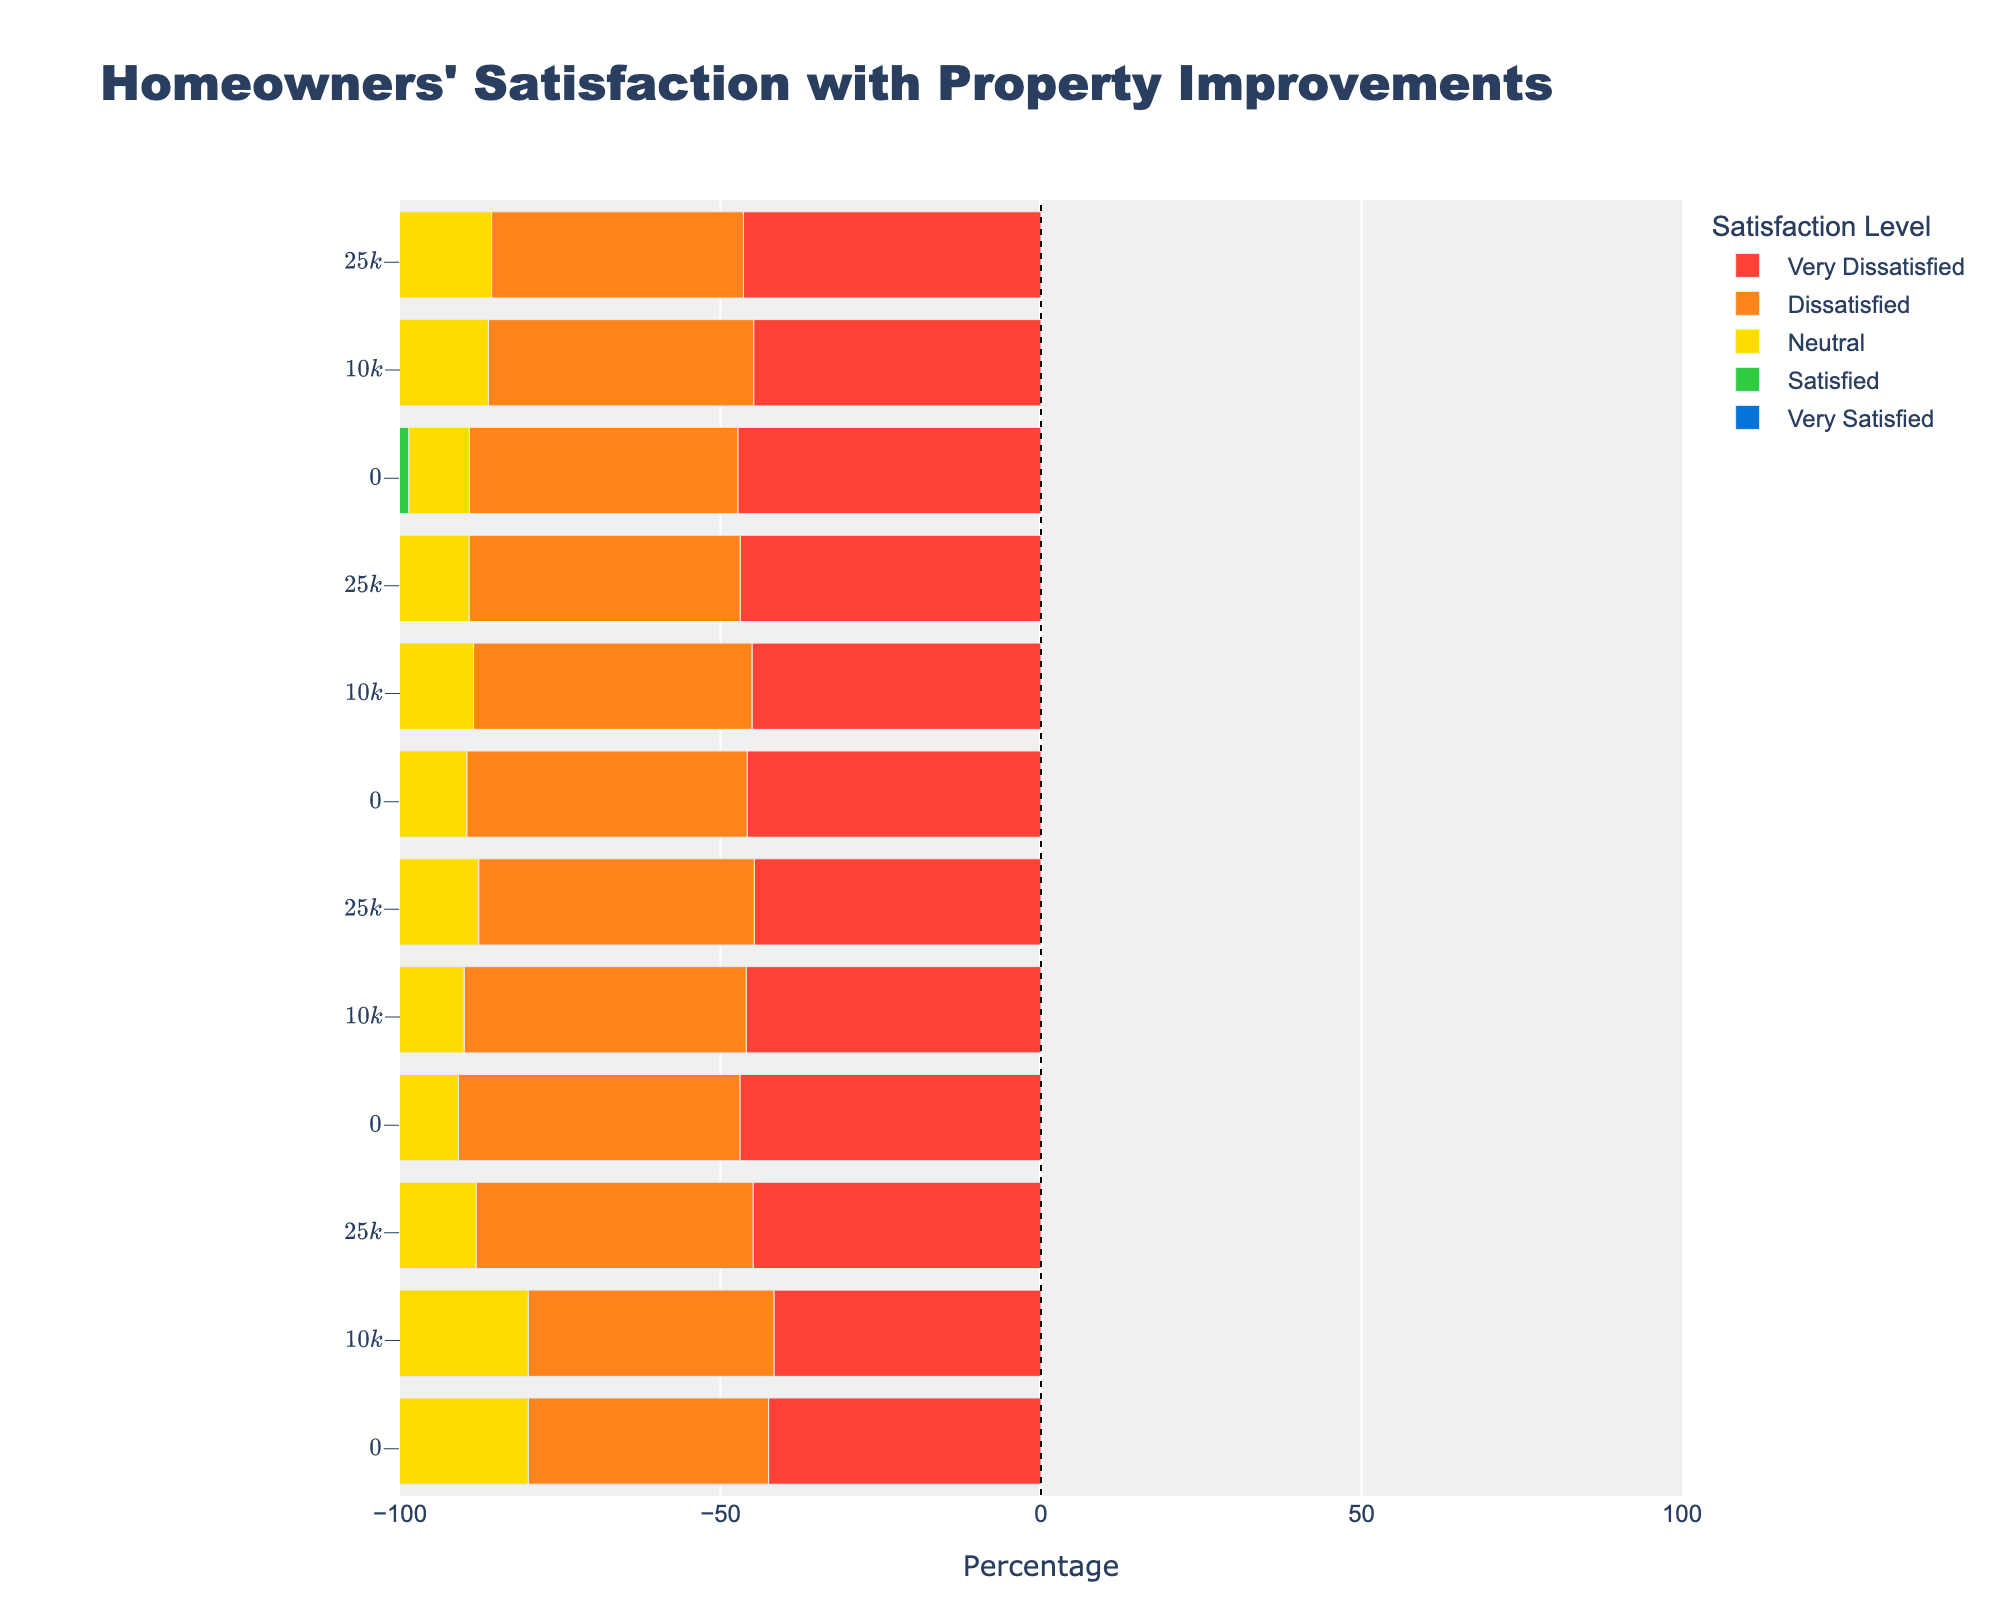Which property improvement has the highest percentage of very satisfied homeowners in the $25k-$50k range? Look at the bars corresponding to 'Very Satisfied' in the $25k-$50k cost range and compare their lengths. The longest bar will tell us the improvement type with the highest percentage. Landscape Improvements has the highest bar at 28%.
Answer: Landscape Improvements Which cost range exhibits the greatest dissatisfaction (Very Dissatisfied) for Kitchen Remodel? Compare the lengths of the bars corresponding to 'Very Dissatisfied' across different cost ranges within Kitchen Remodel. The $25k-$50k range has the longest bar.
Answer: $25k-$50k What is the combined percentage of homeowners who are satisfied or very satisfied with Landscape Improvements in the $10k-$25k range? Add the percentages of 'Satisfied' and 'Very Satisfied' for Landscape Improvements in the $10k-$25k range. 25% (Very Satisfied) + 22% (Satisfied) = 47%.
Answer: 47% Which property improvement has the lowest percentage of neutral satisfaction in the $0-$10k range? Compare the bars corresponding to 'Neutral' for all improvement types in the $0-$10k range. Roofing Replacement has the lowest bar at 15%.
Answer: Roofing Replacement How does the satisfaction level differ between $10k-$25k and $25k-$50k cost ranges for Bathroom Remodel? Compare the bars for each satisfaction level between the $10k-$25k and $25k-$50k ranges for Bathroom Remodel. Analyze each level's shift and observe the changes in bar lengths.
Answer: The $25k-$50k range shows a higher percentage for 'Very Satisfied' and 'Satisfied', and a lower percentage for 'Dissatisfied' and 'Very Dissatisfied' In the Roofing Replacement category, which cost range has the highest combined dissatisfaction percentage (Dissatisfied + Very Dissatisfied)? Add the percentages of 'Dissatisfied' and 'Very Dissatisfied' for each cost range within Roofing Replacement. The $25k-$50k range has the highest combined value (6% Dissatisfied + 2% Very Dissatisfied).
Answer: $25k-$50k How do the satisfaction percentages of a Kitchen Remodel in the $10k-$25k range compare to those in the $0-$10k range? Compare the bars for each satisfaction level between $10k-$25k and $0-$10k ranges for Kitchen Remodel. Observe the changes in bar lengths: 'Very Satisfied' increases (20% vs. 15%), 'Satisfied' increases (18% vs. 10%), and other satisfaction levels show minor changes.
Answer: Higher satisfaction in the $10k-$25k range What percentage of homeowners are neutral or dissatisfied with Landscape Improvements in the $25k-$50k range? Sum the percentages of 'Neutral' and 'Dissatisfied' for Landscape Improvements in the $25k-$50k range. 10% (Neutral) + 5% (Dissatisfied) = 15%.
Answer: 15% 